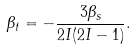Convert formula to latex. <formula><loc_0><loc_0><loc_500><loc_500>\beta _ { t } = - \frac { 3 \beta _ { s } } { 2 I ( 2 I - 1 ) } .</formula> 